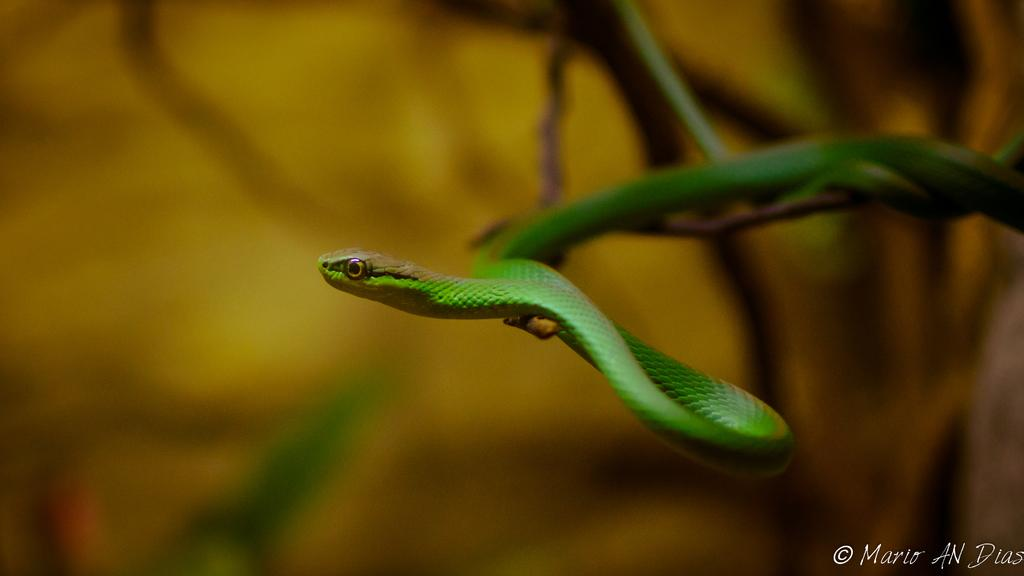What type of animal is present in the image? There is a snake in the image. What color is the snake? The snake is green in color. What type of division is being performed by the pig on the slope in the image? There is no pig or slope present in the image, and therefore no division is being performed. 